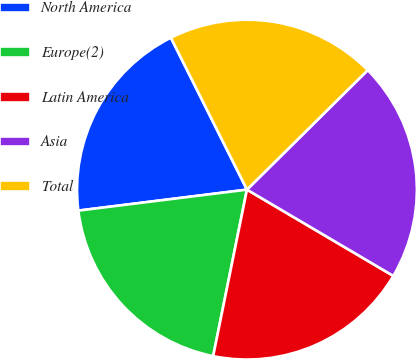Convert chart to OTSL. <chart><loc_0><loc_0><loc_500><loc_500><pie_chart><fcel>North America<fcel>Europe(2)<fcel>Latin America<fcel>Asia<fcel>Total<nl><fcel>19.58%<fcel>19.84%<fcel>19.71%<fcel>20.89%<fcel>19.97%<nl></chart> 